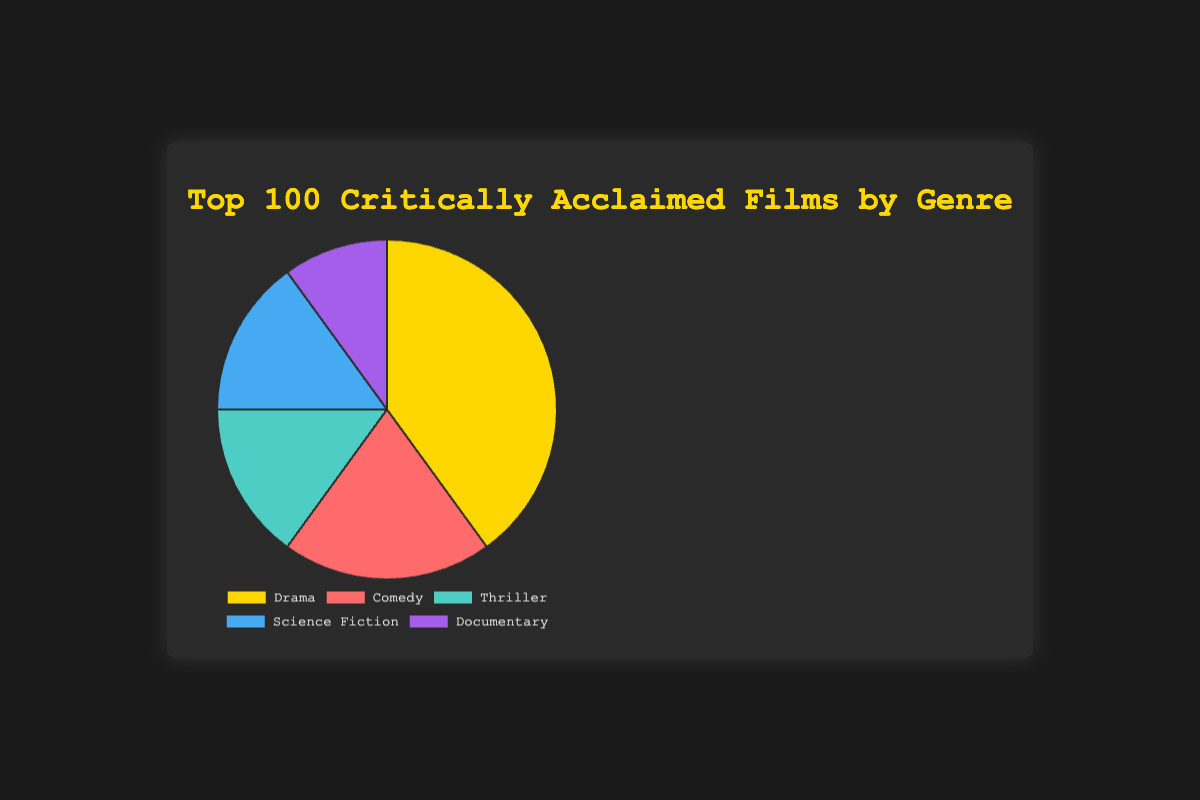What percentage of the top 100 critically acclaimed films belong to the Drama genre? Look at the figure and locate the Drama segment. The percentage is directly given as 40%.
Answer: 40% Which genre appears most frequently among the top 100 critically acclaimed films? Identify the genre with the largest slice in the pie chart. The Drama genre has the largest slice.
Answer: Drama What is the combined percentage of Thriller and Science Fiction films among the top 100 critically acclaimed films? Find the individual percentages for Thriller (15%) and Science Fiction (15%) and add them together: 15% + 15% = 30%.
Answer: 30% How much less is the percentage of Documentary films compared to Comedy films? Find the individual percentages for Documentary (10%) and Comedy (20%). Subtract the smaller percentage from the larger one: 20% - 10% = 10%.
Answer: 10% Which genres have the same percentage among the top 100 critically acclaimed films? Look for segments in the pie chart that have equal sizes. Both Thriller and Science Fiction have 15%.
Answer: Thriller, Science Fiction What is the average percentage of all the genres in the pie chart? Sum all the percentages (40% + 20% + 15% + 15% + 10% = 100%) and divide by the number of genres (5). 100% / 5 = 20%.
Answer: 20% If a genre were to be split equally between Drama and another genre, making the new genre 25%, which current genre would that be? Identify a genre whose percentage is closest to 50%. Since there is no such genre, the genre closest to 50% that sum of two equidistant percentages would make sense. None of the genres sums to 50%.
Answer: None What color represents the Documentary genre in the chart? Visually locate the Documentary segment and identify its color, which is the segment that looks purple.
Answer: Purple Which genre has twice the percentage of Documentary in the chart? Look for a genre whose percentage is double that of Documentary (10% * 2 = 20%). Comedy has 20%.
Answer: Comedy 